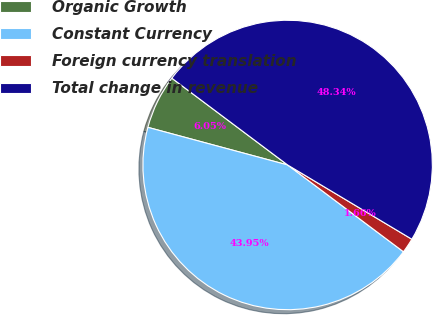Convert chart. <chart><loc_0><loc_0><loc_500><loc_500><pie_chart><fcel>Organic Growth<fcel>Constant Currency<fcel>Foreign currency translation<fcel>Total change in revenue<nl><fcel>6.05%<fcel>43.95%<fcel>1.66%<fcel>48.34%<nl></chart> 